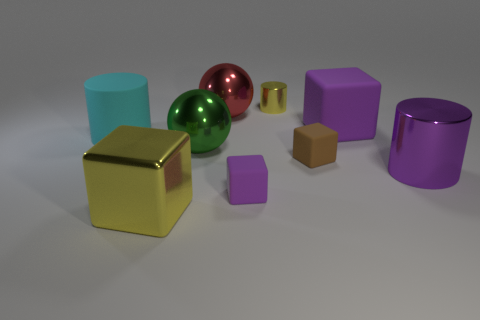Add 1 yellow matte cubes. How many objects exist? 10 Subtract all blocks. How many objects are left? 5 Add 6 large purple blocks. How many large purple blocks exist? 7 Subtract 0 gray cylinders. How many objects are left? 9 Subtract all small brown rubber objects. Subtract all big purple rubber blocks. How many objects are left? 7 Add 9 large purple metallic objects. How many large purple metallic objects are left? 10 